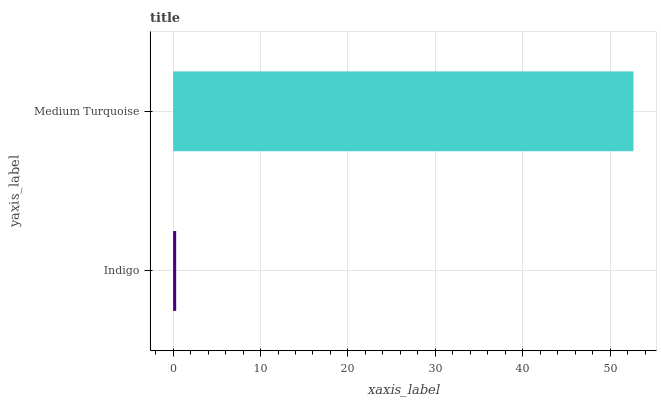Is Indigo the minimum?
Answer yes or no. Yes. Is Medium Turquoise the maximum?
Answer yes or no. Yes. Is Medium Turquoise the minimum?
Answer yes or no. No. Is Medium Turquoise greater than Indigo?
Answer yes or no. Yes. Is Indigo less than Medium Turquoise?
Answer yes or no. Yes. Is Indigo greater than Medium Turquoise?
Answer yes or no. No. Is Medium Turquoise less than Indigo?
Answer yes or no. No. Is Medium Turquoise the high median?
Answer yes or no. Yes. Is Indigo the low median?
Answer yes or no. Yes. Is Indigo the high median?
Answer yes or no. No. Is Medium Turquoise the low median?
Answer yes or no. No. 